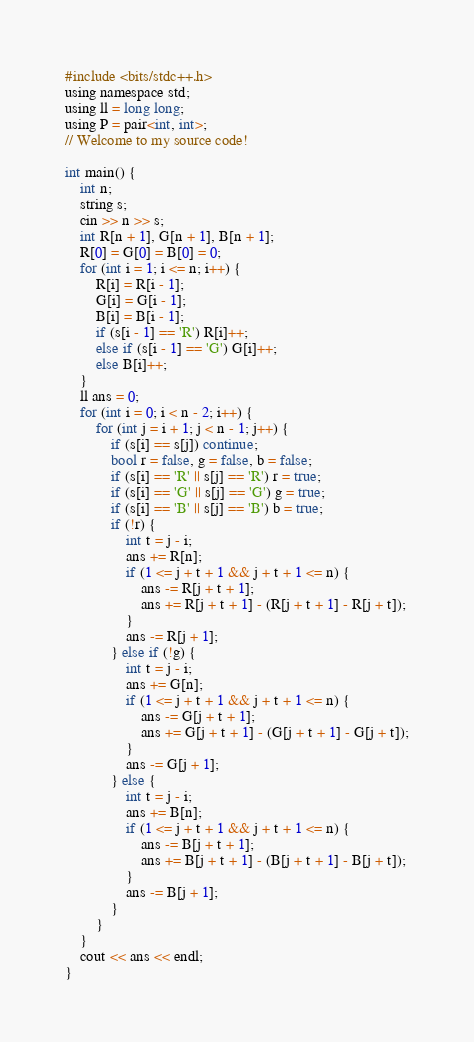<code> <loc_0><loc_0><loc_500><loc_500><_C_>#include <bits/stdc++.h>
using namespace std;
using ll = long long;
using P = pair<int, int>;
// Welcome to my source code!

int main() {
    int n;
    string s;
    cin >> n >> s;
    int R[n + 1], G[n + 1], B[n + 1];
    R[0] = G[0] = B[0] = 0;
    for (int i = 1; i <= n; i++) {
        R[i] = R[i - 1];
        G[i] = G[i - 1];
        B[i] = B[i - 1];
        if (s[i - 1] == 'R') R[i]++;
        else if (s[i - 1] == 'G') G[i]++;
        else B[i]++;
    }
    ll ans = 0;
    for (int i = 0; i < n - 2; i++) {
        for (int j = i + 1; j < n - 1; j++) {
            if (s[i] == s[j]) continue;
            bool r = false, g = false, b = false;
            if (s[i] == 'R' || s[j] == 'R') r = true;
            if (s[i] == 'G' || s[j] == 'G') g = true;
            if (s[i] == 'B' || s[j] == 'B') b = true;
            if (!r) {
                int t = j - i;
                ans += R[n];
                if (1 <= j + t + 1 && j + t + 1 <= n) {
                    ans -= R[j + t + 1];
                    ans += R[j + t + 1] - (R[j + t + 1] - R[j + t]);
                }
                ans -= R[j + 1];
            } else if (!g) {
                int t = j - i;
                ans += G[n];
                if (1 <= j + t + 1 && j + t + 1 <= n) {
                    ans -= G[j + t + 1];
                    ans += G[j + t + 1] - (G[j + t + 1] - G[j + t]);
                }
                ans -= G[j + 1];
            } else {
                int t = j - i;
                ans += B[n];
                if (1 <= j + t + 1 && j + t + 1 <= n) {
                    ans -= B[j + t + 1];
                    ans += B[j + t + 1] - (B[j + t + 1] - B[j + t]);
                }
                ans -= B[j + 1];
            }
        }
    }
    cout << ans << endl;
}</code> 